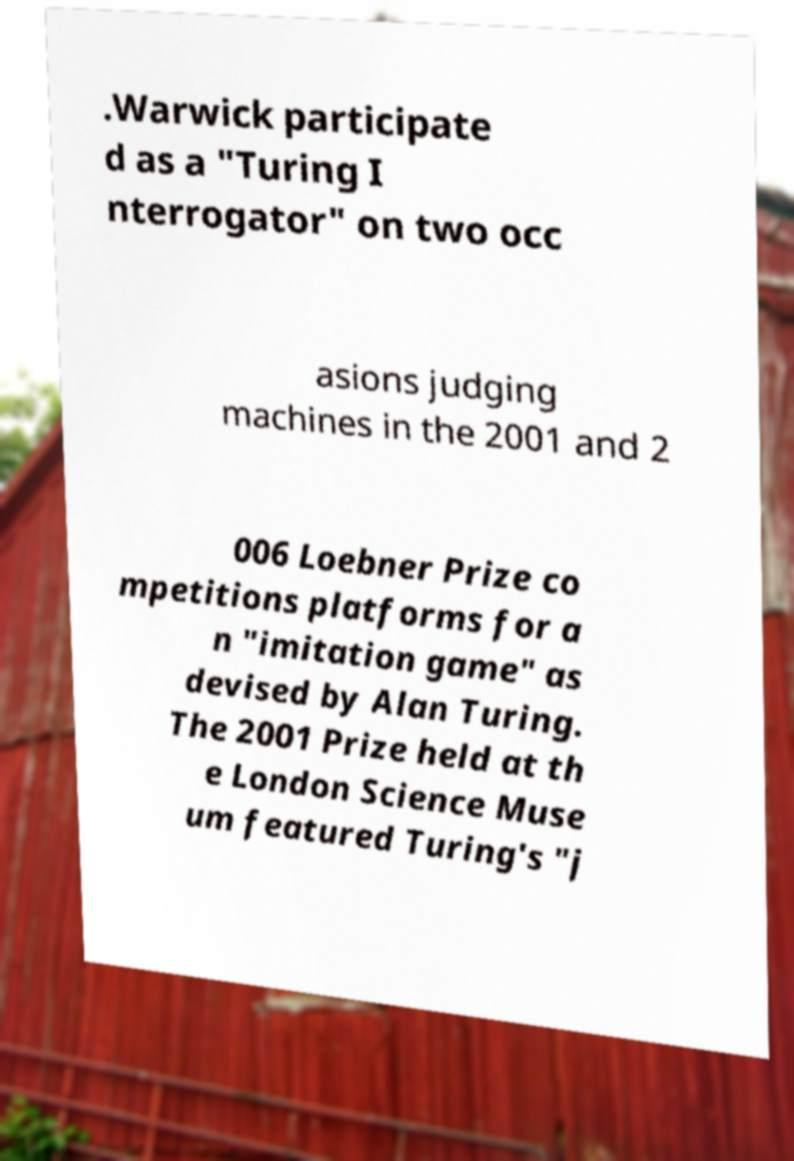There's text embedded in this image that I need extracted. Can you transcribe it verbatim? .Warwick participate d as a "Turing I nterrogator" on two occ asions judging machines in the 2001 and 2 006 Loebner Prize co mpetitions platforms for a n "imitation game" as devised by Alan Turing. The 2001 Prize held at th e London Science Muse um featured Turing's "j 